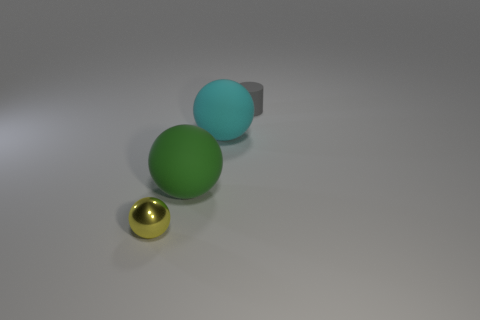Add 4 cyan rubber things. How many objects exist? 8 Subtract all spheres. How many objects are left? 1 Add 2 rubber objects. How many rubber objects are left? 5 Add 4 gray rubber cylinders. How many gray rubber cylinders exist? 5 Subtract 0 gray cubes. How many objects are left? 4 Subtract all tiny metal spheres. Subtract all small things. How many objects are left? 1 